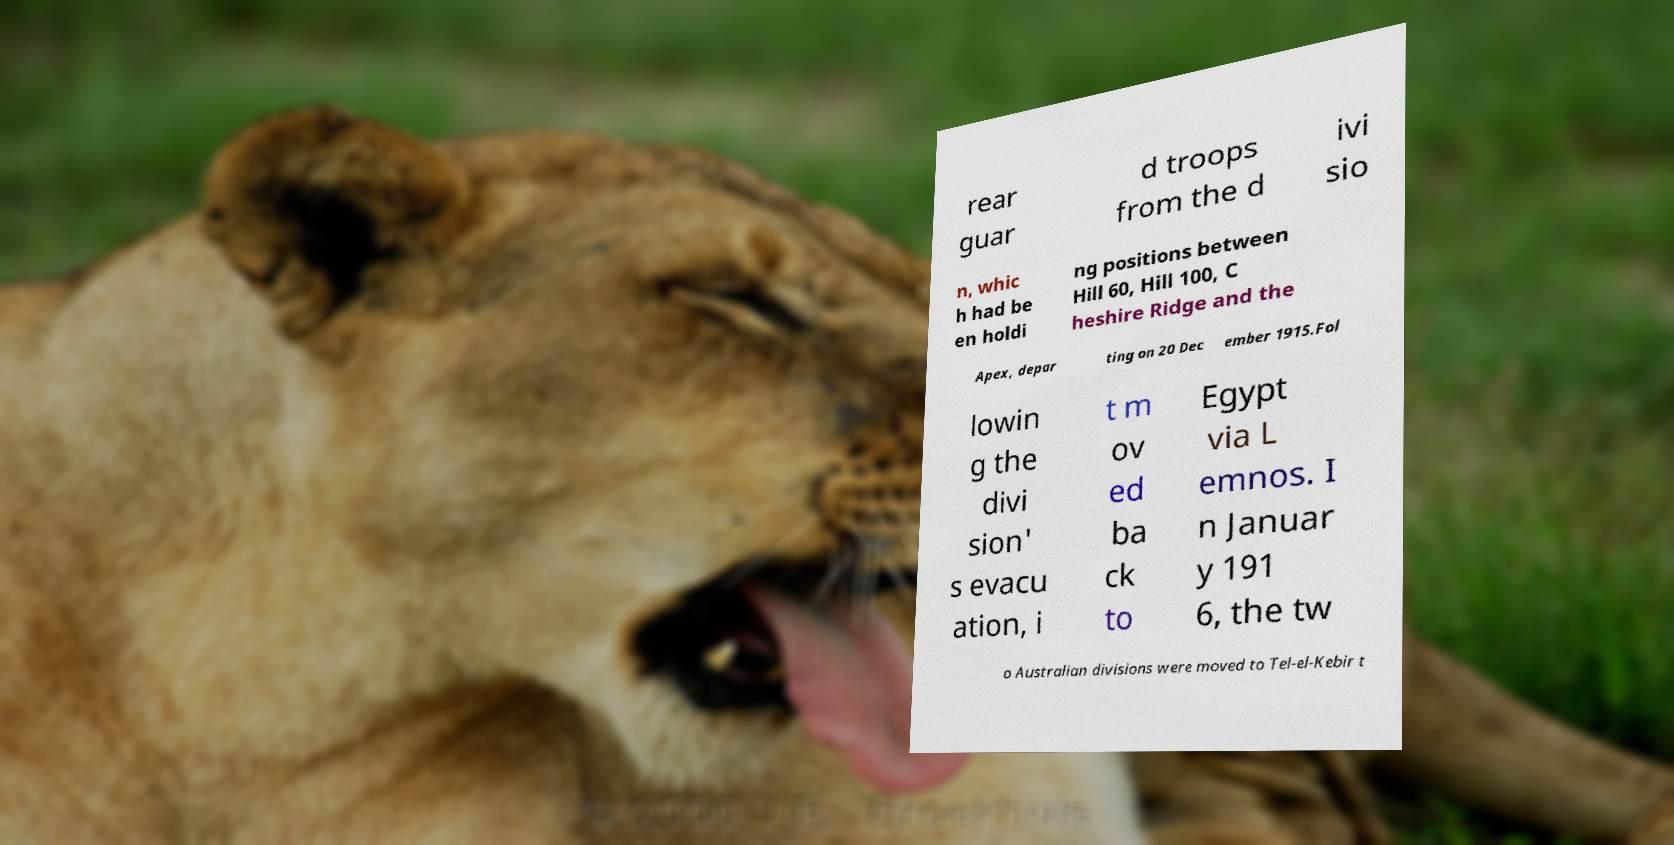For documentation purposes, I need the text within this image transcribed. Could you provide that? rear guar d troops from the d ivi sio n, whic h had be en holdi ng positions between Hill 60, Hill 100, C heshire Ridge and the Apex, depar ting on 20 Dec ember 1915.Fol lowin g the divi sion' s evacu ation, i t m ov ed ba ck to Egypt via L emnos. I n Januar y 191 6, the tw o Australian divisions were moved to Tel-el-Kebir t 